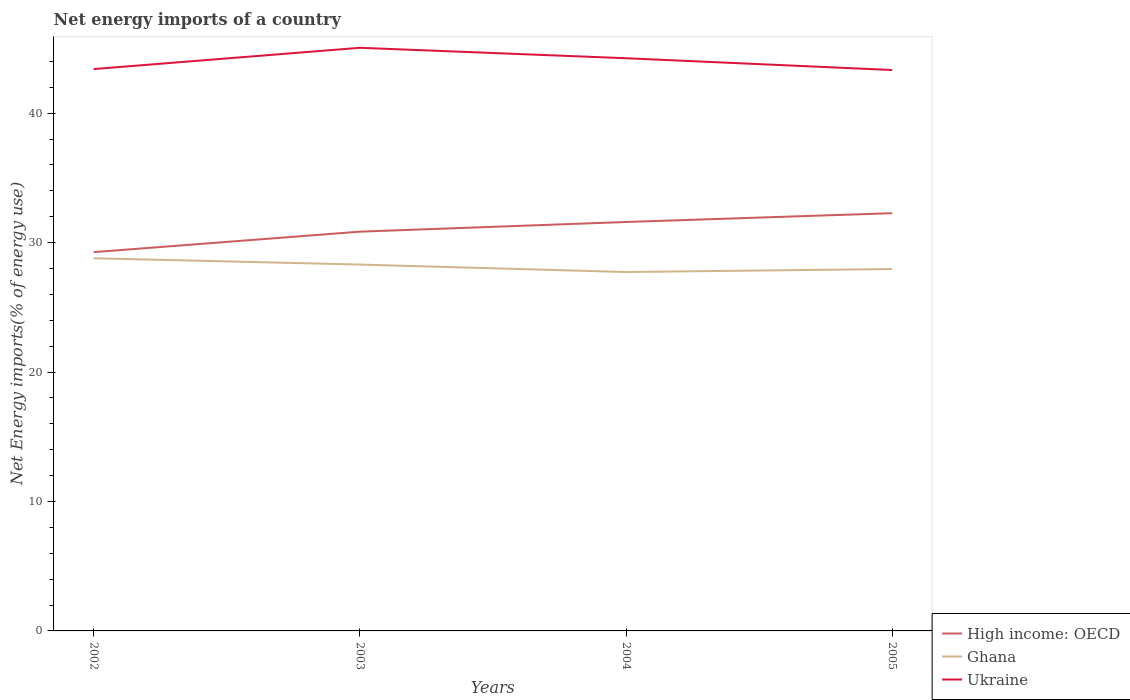Is the number of lines equal to the number of legend labels?
Make the answer very short. Yes. Across all years, what is the maximum net energy imports in Ghana?
Offer a terse response. 27.73. What is the total net energy imports in Ghana in the graph?
Your answer should be compact. 1.06. What is the difference between the highest and the second highest net energy imports in Ukraine?
Make the answer very short. 1.72. Is the net energy imports in Ukraine strictly greater than the net energy imports in Ghana over the years?
Your answer should be very brief. No. How many years are there in the graph?
Offer a very short reply. 4. Are the values on the major ticks of Y-axis written in scientific E-notation?
Your response must be concise. No. Does the graph contain grids?
Offer a very short reply. No. Where does the legend appear in the graph?
Your answer should be very brief. Bottom right. What is the title of the graph?
Your response must be concise. Net energy imports of a country. Does "Antigua and Barbuda" appear as one of the legend labels in the graph?
Offer a terse response. No. What is the label or title of the Y-axis?
Give a very brief answer. Net Energy imports(% of energy use). What is the Net Energy imports(% of energy use) of High income: OECD in 2002?
Provide a short and direct response. 29.26. What is the Net Energy imports(% of energy use) in Ghana in 2002?
Offer a very short reply. 28.79. What is the Net Energy imports(% of energy use) of Ukraine in 2002?
Offer a terse response. 43.4. What is the Net Energy imports(% of energy use) of High income: OECD in 2003?
Your response must be concise. 30.84. What is the Net Energy imports(% of energy use) in Ghana in 2003?
Provide a short and direct response. 28.3. What is the Net Energy imports(% of energy use) of Ukraine in 2003?
Give a very brief answer. 45.05. What is the Net Energy imports(% of energy use) in High income: OECD in 2004?
Ensure brevity in your answer.  31.59. What is the Net Energy imports(% of energy use) of Ghana in 2004?
Give a very brief answer. 27.73. What is the Net Energy imports(% of energy use) of Ukraine in 2004?
Keep it short and to the point. 44.24. What is the Net Energy imports(% of energy use) of High income: OECD in 2005?
Provide a short and direct response. 32.27. What is the Net Energy imports(% of energy use) in Ghana in 2005?
Your answer should be very brief. 27.96. What is the Net Energy imports(% of energy use) in Ukraine in 2005?
Offer a very short reply. 43.33. Across all years, what is the maximum Net Energy imports(% of energy use) of High income: OECD?
Your answer should be compact. 32.27. Across all years, what is the maximum Net Energy imports(% of energy use) of Ghana?
Provide a succinct answer. 28.79. Across all years, what is the maximum Net Energy imports(% of energy use) of Ukraine?
Provide a succinct answer. 45.05. Across all years, what is the minimum Net Energy imports(% of energy use) of High income: OECD?
Your answer should be compact. 29.26. Across all years, what is the minimum Net Energy imports(% of energy use) of Ghana?
Offer a very short reply. 27.73. Across all years, what is the minimum Net Energy imports(% of energy use) of Ukraine?
Give a very brief answer. 43.33. What is the total Net Energy imports(% of energy use) in High income: OECD in the graph?
Keep it short and to the point. 123.97. What is the total Net Energy imports(% of energy use) in Ghana in the graph?
Offer a very short reply. 112.78. What is the total Net Energy imports(% of energy use) of Ukraine in the graph?
Your answer should be very brief. 176.02. What is the difference between the Net Energy imports(% of energy use) of High income: OECD in 2002 and that in 2003?
Offer a very short reply. -1.58. What is the difference between the Net Energy imports(% of energy use) of Ghana in 2002 and that in 2003?
Your response must be concise. 0.49. What is the difference between the Net Energy imports(% of energy use) in Ukraine in 2002 and that in 2003?
Ensure brevity in your answer.  -1.64. What is the difference between the Net Energy imports(% of energy use) of High income: OECD in 2002 and that in 2004?
Your answer should be very brief. -2.33. What is the difference between the Net Energy imports(% of energy use) in Ghana in 2002 and that in 2004?
Offer a very short reply. 1.06. What is the difference between the Net Energy imports(% of energy use) in Ukraine in 2002 and that in 2004?
Give a very brief answer. -0.84. What is the difference between the Net Energy imports(% of energy use) of High income: OECD in 2002 and that in 2005?
Your response must be concise. -3.01. What is the difference between the Net Energy imports(% of energy use) of Ghana in 2002 and that in 2005?
Your response must be concise. 0.83. What is the difference between the Net Energy imports(% of energy use) of Ukraine in 2002 and that in 2005?
Your answer should be compact. 0.07. What is the difference between the Net Energy imports(% of energy use) of High income: OECD in 2003 and that in 2004?
Your answer should be very brief. -0.75. What is the difference between the Net Energy imports(% of energy use) of Ghana in 2003 and that in 2004?
Give a very brief answer. 0.58. What is the difference between the Net Energy imports(% of energy use) of Ukraine in 2003 and that in 2004?
Your response must be concise. 0.81. What is the difference between the Net Energy imports(% of energy use) in High income: OECD in 2003 and that in 2005?
Ensure brevity in your answer.  -1.43. What is the difference between the Net Energy imports(% of energy use) in Ghana in 2003 and that in 2005?
Keep it short and to the point. 0.35. What is the difference between the Net Energy imports(% of energy use) in Ukraine in 2003 and that in 2005?
Give a very brief answer. 1.72. What is the difference between the Net Energy imports(% of energy use) of High income: OECD in 2004 and that in 2005?
Your response must be concise. -0.68. What is the difference between the Net Energy imports(% of energy use) in Ghana in 2004 and that in 2005?
Offer a terse response. -0.23. What is the difference between the Net Energy imports(% of energy use) in Ukraine in 2004 and that in 2005?
Your response must be concise. 0.91. What is the difference between the Net Energy imports(% of energy use) of High income: OECD in 2002 and the Net Energy imports(% of energy use) of Ghana in 2003?
Ensure brevity in your answer.  0.96. What is the difference between the Net Energy imports(% of energy use) in High income: OECD in 2002 and the Net Energy imports(% of energy use) in Ukraine in 2003?
Give a very brief answer. -15.79. What is the difference between the Net Energy imports(% of energy use) in Ghana in 2002 and the Net Energy imports(% of energy use) in Ukraine in 2003?
Give a very brief answer. -16.26. What is the difference between the Net Energy imports(% of energy use) in High income: OECD in 2002 and the Net Energy imports(% of energy use) in Ghana in 2004?
Ensure brevity in your answer.  1.54. What is the difference between the Net Energy imports(% of energy use) in High income: OECD in 2002 and the Net Energy imports(% of energy use) in Ukraine in 2004?
Give a very brief answer. -14.98. What is the difference between the Net Energy imports(% of energy use) of Ghana in 2002 and the Net Energy imports(% of energy use) of Ukraine in 2004?
Provide a short and direct response. -15.45. What is the difference between the Net Energy imports(% of energy use) of High income: OECD in 2002 and the Net Energy imports(% of energy use) of Ghana in 2005?
Your response must be concise. 1.3. What is the difference between the Net Energy imports(% of energy use) of High income: OECD in 2002 and the Net Energy imports(% of energy use) of Ukraine in 2005?
Make the answer very short. -14.07. What is the difference between the Net Energy imports(% of energy use) of Ghana in 2002 and the Net Energy imports(% of energy use) of Ukraine in 2005?
Keep it short and to the point. -14.54. What is the difference between the Net Energy imports(% of energy use) of High income: OECD in 2003 and the Net Energy imports(% of energy use) of Ghana in 2004?
Make the answer very short. 3.12. What is the difference between the Net Energy imports(% of energy use) of High income: OECD in 2003 and the Net Energy imports(% of energy use) of Ukraine in 2004?
Your response must be concise. -13.4. What is the difference between the Net Energy imports(% of energy use) in Ghana in 2003 and the Net Energy imports(% of energy use) in Ukraine in 2004?
Offer a terse response. -15.94. What is the difference between the Net Energy imports(% of energy use) of High income: OECD in 2003 and the Net Energy imports(% of energy use) of Ghana in 2005?
Offer a very short reply. 2.89. What is the difference between the Net Energy imports(% of energy use) of High income: OECD in 2003 and the Net Energy imports(% of energy use) of Ukraine in 2005?
Offer a terse response. -12.49. What is the difference between the Net Energy imports(% of energy use) of Ghana in 2003 and the Net Energy imports(% of energy use) of Ukraine in 2005?
Make the answer very short. -15.03. What is the difference between the Net Energy imports(% of energy use) in High income: OECD in 2004 and the Net Energy imports(% of energy use) in Ghana in 2005?
Your answer should be compact. 3.63. What is the difference between the Net Energy imports(% of energy use) of High income: OECD in 2004 and the Net Energy imports(% of energy use) of Ukraine in 2005?
Keep it short and to the point. -11.74. What is the difference between the Net Energy imports(% of energy use) in Ghana in 2004 and the Net Energy imports(% of energy use) in Ukraine in 2005?
Your response must be concise. -15.6. What is the average Net Energy imports(% of energy use) of High income: OECD per year?
Ensure brevity in your answer.  30.99. What is the average Net Energy imports(% of energy use) of Ghana per year?
Offer a very short reply. 28.19. What is the average Net Energy imports(% of energy use) of Ukraine per year?
Offer a terse response. 44.01. In the year 2002, what is the difference between the Net Energy imports(% of energy use) of High income: OECD and Net Energy imports(% of energy use) of Ghana?
Keep it short and to the point. 0.47. In the year 2002, what is the difference between the Net Energy imports(% of energy use) in High income: OECD and Net Energy imports(% of energy use) in Ukraine?
Offer a terse response. -14.14. In the year 2002, what is the difference between the Net Energy imports(% of energy use) of Ghana and Net Energy imports(% of energy use) of Ukraine?
Your answer should be very brief. -14.61. In the year 2003, what is the difference between the Net Energy imports(% of energy use) of High income: OECD and Net Energy imports(% of energy use) of Ghana?
Your answer should be very brief. 2.54. In the year 2003, what is the difference between the Net Energy imports(% of energy use) in High income: OECD and Net Energy imports(% of energy use) in Ukraine?
Ensure brevity in your answer.  -14.2. In the year 2003, what is the difference between the Net Energy imports(% of energy use) of Ghana and Net Energy imports(% of energy use) of Ukraine?
Ensure brevity in your answer.  -16.75. In the year 2004, what is the difference between the Net Energy imports(% of energy use) of High income: OECD and Net Energy imports(% of energy use) of Ghana?
Your response must be concise. 3.87. In the year 2004, what is the difference between the Net Energy imports(% of energy use) in High income: OECD and Net Energy imports(% of energy use) in Ukraine?
Offer a very short reply. -12.65. In the year 2004, what is the difference between the Net Energy imports(% of energy use) of Ghana and Net Energy imports(% of energy use) of Ukraine?
Your response must be concise. -16.51. In the year 2005, what is the difference between the Net Energy imports(% of energy use) of High income: OECD and Net Energy imports(% of energy use) of Ghana?
Make the answer very short. 4.31. In the year 2005, what is the difference between the Net Energy imports(% of energy use) of High income: OECD and Net Energy imports(% of energy use) of Ukraine?
Offer a terse response. -11.06. In the year 2005, what is the difference between the Net Energy imports(% of energy use) in Ghana and Net Energy imports(% of energy use) in Ukraine?
Give a very brief answer. -15.37. What is the ratio of the Net Energy imports(% of energy use) of High income: OECD in 2002 to that in 2003?
Give a very brief answer. 0.95. What is the ratio of the Net Energy imports(% of energy use) of Ghana in 2002 to that in 2003?
Offer a very short reply. 1.02. What is the ratio of the Net Energy imports(% of energy use) in Ukraine in 2002 to that in 2003?
Provide a short and direct response. 0.96. What is the ratio of the Net Energy imports(% of energy use) of High income: OECD in 2002 to that in 2004?
Give a very brief answer. 0.93. What is the ratio of the Net Energy imports(% of energy use) in Ghana in 2002 to that in 2004?
Offer a very short reply. 1.04. What is the ratio of the Net Energy imports(% of energy use) of Ukraine in 2002 to that in 2004?
Provide a short and direct response. 0.98. What is the ratio of the Net Energy imports(% of energy use) in High income: OECD in 2002 to that in 2005?
Give a very brief answer. 0.91. What is the ratio of the Net Energy imports(% of energy use) of Ghana in 2002 to that in 2005?
Your answer should be compact. 1.03. What is the ratio of the Net Energy imports(% of energy use) of Ukraine in 2002 to that in 2005?
Make the answer very short. 1. What is the ratio of the Net Energy imports(% of energy use) of High income: OECD in 2003 to that in 2004?
Give a very brief answer. 0.98. What is the ratio of the Net Energy imports(% of energy use) in Ghana in 2003 to that in 2004?
Your response must be concise. 1.02. What is the ratio of the Net Energy imports(% of energy use) in Ukraine in 2003 to that in 2004?
Your answer should be compact. 1.02. What is the ratio of the Net Energy imports(% of energy use) of High income: OECD in 2003 to that in 2005?
Provide a short and direct response. 0.96. What is the ratio of the Net Energy imports(% of energy use) in Ghana in 2003 to that in 2005?
Provide a succinct answer. 1.01. What is the ratio of the Net Energy imports(% of energy use) of Ukraine in 2003 to that in 2005?
Provide a short and direct response. 1.04. What is the ratio of the Net Energy imports(% of energy use) of High income: OECD in 2004 to that in 2005?
Make the answer very short. 0.98. What is the ratio of the Net Energy imports(% of energy use) of Ghana in 2004 to that in 2005?
Offer a very short reply. 0.99. What is the difference between the highest and the second highest Net Energy imports(% of energy use) in High income: OECD?
Ensure brevity in your answer.  0.68. What is the difference between the highest and the second highest Net Energy imports(% of energy use) in Ghana?
Provide a short and direct response. 0.49. What is the difference between the highest and the second highest Net Energy imports(% of energy use) in Ukraine?
Ensure brevity in your answer.  0.81. What is the difference between the highest and the lowest Net Energy imports(% of energy use) in High income: OECD?
Your answer should be compact. 3.01. What is the difference between the highest and the lowest Net Energy imports(% of energy use) of Ghana?
Your answer should be very brief. 1.06. What is the difference between the highest and the lowest Net Energy imports(% of energy use) in Ukraine?
Ensure brevity in your answer.  1.72. 